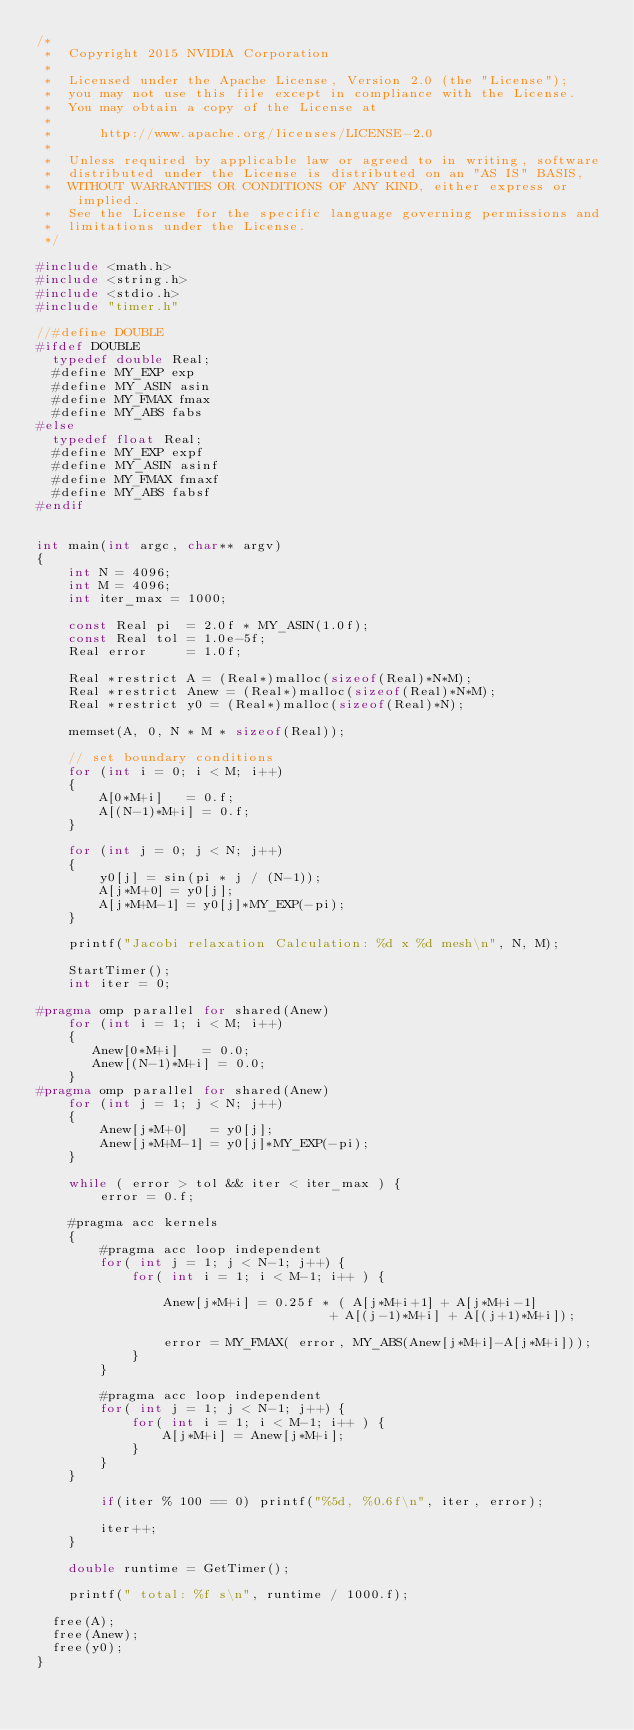<code> <loc_0><loc_0><loc_500><loc_500><_C++_>/*
 *  Copyright 2015 NVIDIA Corporation
 *
 *  Licensed under the Apache License, Version 2.0 (the "License");
 *  you may not use this file except in compliance with the License.
 *  You may obtain a copy of the License at
 *
 *      http://www.apache.org/licenses/LICENSE-2.0
 *
 *  Unless required by applicable law or agreed to in writing, software
 *  distributed under the License is distributed on an "AS IS" BASIS,
 *  WITHOUT WARRANTIES OR CONDITIONS OF ANY KIND, either express or implied.
 *  See the License for the specific language governing permissions and
 *  limitations under the License.
 */

#include <math.h>
#include <string.h>
#include <stdio.h>
#include "timer.h"

//#define DOUBLE
#ifdef DOUBLE
	typedef double Real;
	#define MY_EXP exp
	#define MY_ASIN asin
	#define MY_FMAX fmax
	#define MY_ABS fabs
#else
	typedef float Real;	
	#define MY_EXP expf
	#define MY_ASIN asinf
	#define MY_FMAX fmaxf
	#define MY_ABS fabsf
#endif


int main(int argc, char** argv)
{
    int N = 4096;
    int M = 4096;
    int iter_max = 1000;
    
    const Real pi  = 2.0f * MY_ASIN(1.0f);
    const Real tol = 1.0e-5f;
    Real error     = 1.0f;
    
    Real *restrict A = (Real*)malloc(sizeof(Real)*N*M);
    Real *restrict Anew = (Real*)malloc(sizeof(Real)*N*M);
    Real *restrict y0 = (Real*)malloc(sizeof(Real)*N);

    memset(A, 0, N * M * sizeof(Real));
    
    // set boundary conditions
    for (int i = 0; i < M; i++)
    {
        A[0*M+i]   = 0.f;
        A[(N-1)*M+i] = 0.f;
    }
    
    for (int j = 0; j < N; j++)
    {
        y0[j] = sin(pi * j / (N-1));
        A[j*M+0] = y0[j];
        A[j*M+M-1] = y0[j]*MY_EXP(-pi);
    }
    
    printf("Jacobi relaxation Calculation: %d x %d mesh\n", N, M);
    
    StartTimer();
    int iter = 0;
    
#pragma omp parallel for shared(Anew)
    for (int i = 1; i < M; i++)
    {
       Anew[0*M+i]   = 0.0;
       Anew[(N-1)*M+i] = 0.0;
    }
#pragma omp parallel for shared(Anew)    
    for (int j = 1; j < N; j++)
    {
        Anew[j*M+0]   = y0[j];
        Anew[j*M+M-1] = y0[j]*MY_EXP(-pi);
    }
    
    while ( error > tol && iter < iter_max ) {
        error = 0.f;

    #pragma acc kernels 
    {
        #pragma acc loop independent
        for( int j = 1; j < N-1; j++) {
            for( int i = 1; i < M-1; i++ ) {

                Anew[j*M+i] = 0.25f * ( A[j*M+i+1] + A[j*M+i-1]
                                     + A[(j-1)*M+i] + A[(j+1)*M+i]);

                error = MY_FMAX( error, MY_ABS(Anew[j*M+i]-A[j*M+i]));
            }
        }

        #pragma acc loop independent
        for( int j = 1; j < N-1; j++) {
            for( int i = 1; i < M-1; i++ ) {
                A[j*M+i] = Anew[j*M+i];    
            }
        }
    }

        if(iter % 100 == 0) printf("%5d, %0.6f\n", iter, error);
        
        iter++;
    }

    double runtime = GetTimer();
 
    printf(" total: %f s\n", runtime / 1000.f);
	
	free(A);
	free(Anew);
	free(y0);
}
</code> 